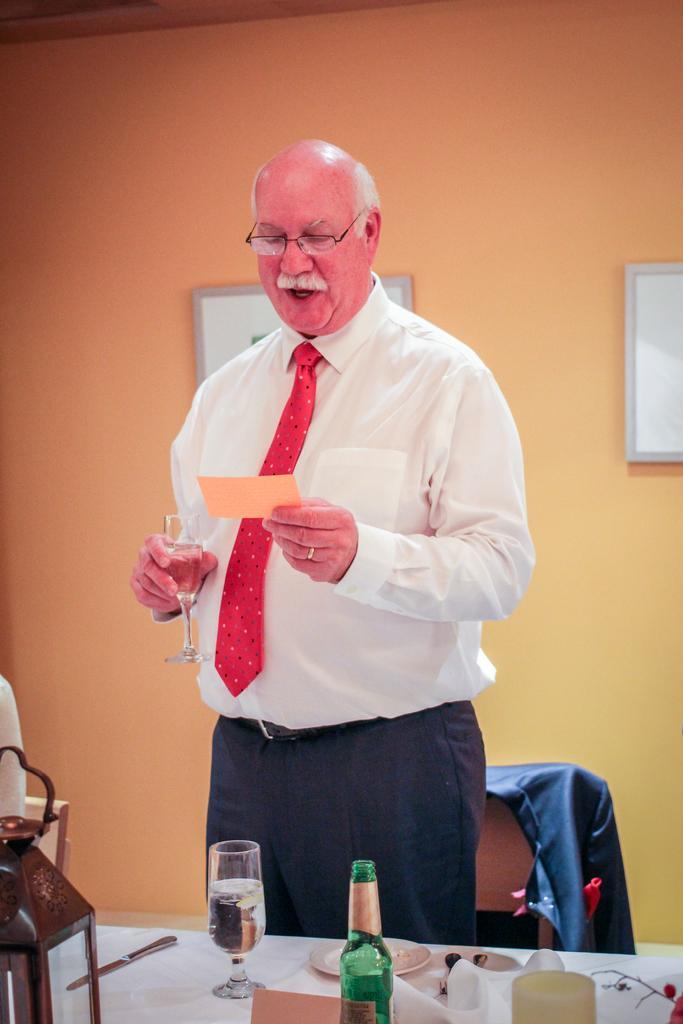Describe this image in one or two sentences. In this image I see a man who is standing and holding a glass and a paper in his hands, I can see a table in front of him on which there is a glass, a bottle, plate, a knife and other things on it. In the background I see the wall. 